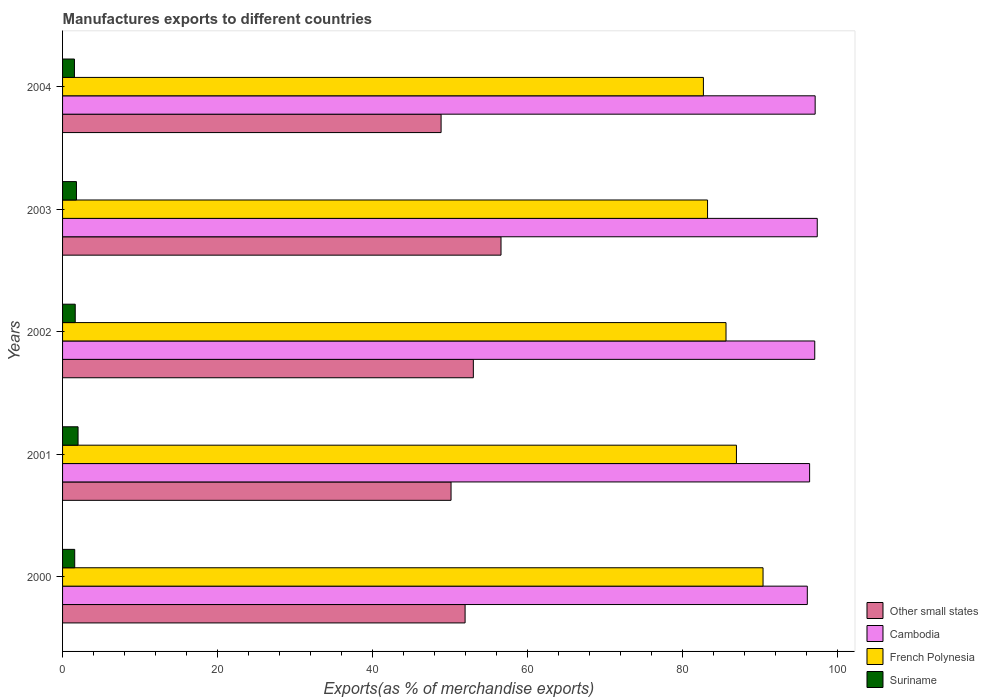How many groups of bars are there?
Keep it short and to the point. 5. How many bars are there on the 3rd tick from the top?
Your response must be concise. 4. What is the label of the 4th group of bars from the top?
Offer a very short reply. 2001. In how many cases, is the number of bars for a given year not equal to the number of legend labels?
Give a very brief answer. 0. What is the percentage of exports to different countries in Suriname in 2004?
Make the answer very short. 1.53. Across all years, what is the maximum percentage of exports to different countries in Other small states?
Ensure brevity in your answer.  56.55. Across all years, what is the minimum percentage of exports to different countries in French Polynesia?
Your answer should be very brief. 82.66. In which year was the percentage of exports to different countries in Suriname minimum?
Ensure brevity in your answer.  2004. What is the total percentage of exports to different countries in Cambodia in the graph?
Your answer should be very brief. 483.84. What is the difference between the percentage of exports to different countries in Cambodia in 2000 and that in 2002?
Keep it short and to the point. -0.96. What is the difference between the percentage of exports to different countries in Other small states in 2000 and the percentage of exports to different countries in French Polynesia in 2003?
Your answer should be compact. -31.27. What is the average percentage of exports to different countries in Other small states per year?
Make the answer very short. 52.08. In the year 2001, what is the difference between the percentage of exports to different countries in Other small states and percentage of exports to different countries in Cambodia?
Offer a very short reply. -46.25. In how many years, is the percentage of exports to different countries in Other small states greater than 88 %?
Your answer should be very brief. 0. What is the ratio of the percentage of exports to different countries in Suriname in 2000 to that in 2003?
Offer a terse response. 0.87. Is the percentage of exports to different countries in French Polynesia in 2001 less than that in 2002?
Keep it short and to the point. No. Is the difference between the percentage of exports to different countries in Other small states in 2002 and 2004 greater than the difference between the percentage of exports to different countries in Cambodia in 2002 and 2004?
Give a very brief answer. Yes. What is the difference between the highest and the second highest percentage of exports to different countries in Other small states?
Offer a very short reply. 3.57. What is the difference between the highest and the lowest percentage of exports to different countries in French Polynesia?
Ensure brevity in your answer.  7.69. In how many years, is the percentage of exports to different countries in Other small states greater than the average percentage of exports to different countries in Other small states taken over all years?
Ensure brevity in your answer.  2. Is the sum of the percentage of exports to different countries in Cambodia in 2003 and 2004 greater than the maximum percentage of exports to different countries in Other small states across all years?
Provide a short and direct response. Yes. What does the 4th bar from the top in 2000 represents?
Your answer should be compact. Other small states. What does the 4th bar from the bottom in 2001 represents?
Your answer should be very brief. Suriname. Is it the case that in every year, the sum of the percentage of exports to different countries in Suriname and percentage of exports to different countries in Cambodia is greater than the percentage of exports to different countries in French Polynesia?
Provide a succinct answer. Yes. How many bars are there?
Make the answer very short. 20. Are all the bars in the graph horizontal?
Your answer should be compact. Yes. Does the graph contain any zero values?
Ensure brevity in your answer.  No. Does the graph contain grids?
Give a very brief answer. No. Where does the legend appear in the graph?
Offer a very short reply. Bottom right. How many legend labels are there?
Offer a very short reply. 4. How are the legend labels stacked?
Your response must be concise. Vertical. What is the title of the graph?
Provide a short and direct response. Manufactures exports to different countries. Does "Georgia" appear as one of the legend labels in the graph?
Provide a succinct answer. No. What is the label or title of the X-axis?
Offer a terse response. Exports(as % of merchandise exports). What is the label or title of the Y-axis?
Give a very brief answer. Years. What is the Exports(as % of merchandise exports) in Other small states in 2000?
Provide a succinct answer. 51.92. What is the Exports(as % of merchandise exports) in Cambodia in 2000?
Offer a very short reply. 96.06. What is the Exports(as % of merchandise exports) of French Polynesia in 2000?
Offer a very short reply. 90.35. What is the Exports(as % of merchandise exports) in Suriname in 2000?
Your answer should be compact. 1.57. What is the Exports(as % of merchandise exports) in Other small states in 2001?
Offer a very short reply. 50.11. What is the Exports(as % of merchandise exports) in Cambodia in 2001?
Your answer should be very brief. 96.35. What is the Exports(as % of merchandise exports) in French Polynesia in 2001?
Make the answer very short. 86.92. What is the Exports(as % of merchandise exports) in Suriname in 2001?
Your response must be concise. 2. What is the Exports(as % of merchandise exports) of Other small states in 2002?
Keep it short and to the point. 52.98. What is the Exports(as % of merchandise exports) of Cambodia in 2002?
Ensure brevity in your answer.  97.02. What is the Exports(as % of merchandise exports) in French Polynesia in 2002?
Make the answer very short. 85.57. What is the Exports(as % of merchandise exports) of Suriname in 2002?
Your answer should be very brief. 1.63. What is the Exports(as % of merchandise exports) of Other small states in 2003?
Offer a terse response. 56.55. What is the Exports(as % of merchandise exports) in Cambodia in 2003?
Offer a terse response. 97.34. What is the Exports(as % of merchandise exports) of French Polynesia in 2003?
Your answer should be very brief. 83.19. What is the Exports(as % of merchandise exports) in Suriname in 2003?
Provide a succinct answer. 1.79. What is the Exports(as % of merchandise exports) in Other small states in 2004?
Offer a very short reply. 48.82. What is the Exports(as % of merchandise exports) in Cambodia in 2004?
Ensure brevity in your answer.  97.07. What is the Exports(as % of merchandise exports) of French Polynesia in 2004?
Provide a succinct answer. 82.66. What is the Exports(as % of merchandise exports) in Suriname in 2004?
Offer a terse response. 1.53. Across all years, what is the maximum Exports(as % of merchandise exports) in Other small states?
Your response must be concise. 56.55. Across all years, what is the maximum Exports(as % of merchandise exports) of Cambodia?
Your answer should be compact. 97.34. Across all years, what is the maximum Exports(as % of merchandise exports) in French Polynesia?
Provide a short and direct response. 90.35. Across all years, what is the maximum Exports(as % of merchandise exports) of Suriname?
Provide a short and direct response. 2. Across all years, what is the minimum Exports(as % of merchandise exports) of Other small states?
Offer a very short reply. 48.82. Across all years, what is the minimum Exports(as % of merchandise exports) in Cambodia?
Your answer should be compact. 96.06. Across all years, what is the minimum Exports(as % of merchandise exports) of French Polynesia?
Keep it short and to the point. 82.66. Across all years, what is the minimum Exports(as % of merchandise exports) in Suriname?
Your answer should be very brief. 1.53. What is the total Exports(as % of merchandise exports) in Other small states in the graph?
Your answer should be very brief. 260.38. What is the total Exports(as % of merchandise exports) of Cambodia in the graph?
Offer a very short reply. 483.84. What is the total Exports(as % of merchandise exports) of French Polynesia in the graph?
Your answer should be compact. 428.68. What is the total Exports(as % of merchandise exports) in Suriname in the graph?
Your response must be concise. 8.52. What is the difference between the Exports(as % of merchandise exports) in Other small states in 2000 and that in 2001?
Your answer should be very brief. 1.81. What is the difference between the Exports(as % of merchandise exports) of Cambodia in 2000 and that in 2001?
Ensure brevity in your answer.  -0.3. What is the difference between the Exports(as % of merchandise exports) in French Polynesia in 2000 and that in 2001?
Your answer should be compact. 3.43. What is the difference between the Exports(as % of merchandise exports) in Suriname in 2000 and that in 2001?
Keep it short and to the point. -0.43. What is the difference between the Exports(as % of merchandise exports) in Other small states in 2000 and that in 2002?
Provide a short and direct response. -1.06. What is the difference between the Exports(as % of merchandise exports) in Cambodia in 2000 and that in 2002?
Provide a succinct answer. -0.96. What is the difference between the Exports(as % of merchandise exports) in French Polynesia in 2000 and that in 2002?
Provide a short and direct response. 4.78. What is the difference between the Exports(as % of merchandise exports) in Suriname in 2000 and that in 2002?
Make the answer very short. -0.07. What is the difference between the Exports(as % of merchandise exports) of Other small states in 2000 and that in 2003?
Provide a short and direct response. -4.63. What is the difference between the Exports(as % of merchandise exports) in Cambodia in 2000 and that in 2003?
Provide a short and direct response. -1.28. What is the difference between the Exports(as % of merchandise exports) in French Polynesia in 2000 and that in 2003?
Offer a very short reply. 7.16. What is the difference between the Exports(as % of merchandise exports) of Suriname in 2000 and that in 2003?
Provide a succinct answer. -0.23. What is the difference between the Exports(as % of merchandise exports) in Other small states in 2000 and that in 2004?
Your answer should be compact. 3.1. What is the difference between the Exports(as % of merchandise exports) of Cambodia in 2000 and that in 2004?
Make the answer very short. -1.01. What is the difference between the Exports(as % of merchandise exports) in French Polynesia in 2000 and that in 2004?
Offer a terse response. 7.69. What is the difference between the Exports(as % of merchandise exports) of Suriname in 2000 and that in 2004?
Provide a succinct answer. 0.04. What is the difference between the Exports(as % of merchandise exports) in Other small states in 2001 and that in 2002?
Offer a very short reply. -2.87. What is the difference between the Exports(as % of merchandise exports) of Cambodia in 2001 and that in 2002?
Make the answer very short. -0.66. What is the difference between the Exports(as % of merchandise exports) of French Polynesia in 2001 and that in 2002?
Provide a succinct answer. 1.35. What is the difference between the Exports(as % of merchandise exports) in Suriname in 2001 and that in 2002?
Offer a very short reply. 0.36. What is the difference between the Exports(as % of merchandise exports) in Other small states in 2001 and that in 2003?
Ensure brevity in your answer.  -6.44. What is the difference between the Exports(as % of merchandise exports) of Cambodia in 2001 and that in 2003?
Offer a very short reply. -0.98. What is the difference between the Exports(as % of merchandise exports) in French Polynesia in 2001 and that in 2003?
Provide a short and direct response. 3.73. What is the difference between the Exports(as % of merchandise exports) of Suriname in 2001 and that in 2003?
Your answer should be compact. 0.21. What is the difference between the Exports(as % of merchandise exports) in Other small states in 2001 and that in 2004?
Ensure brevity in your answer.  1.29. What is the difference between the Exports(as % of merchandise exports) in Cambodia in 2001 and that in 2004?
Provide a short and direct response. -0.72. What is the difference between the Exports(as % of merchandise exports) in French Polynesia in 2001 and that in 2004?
Offer a very short reply. 4.26. What is the difference between the Exports(as % of merchandise exports) in Suriname in 2001 and that in 2004?
Provide a short and direct response. 0.47. What is the difference between the Exports(as % of merchandise exports) of Other small states in 2002 and that in 2003?
Your response must be concise. -3.57. What is the difference between the Exports(as % of merchandise exports) of Cambodia in 2002 and that in 2003?
Give a very brief answer. -0.32. What is the difference between the Exports(as % of merchandise exports) of French Polynesia in 2002 and that in 2003?
Ensure brevity in your answer.  2.38. What is the difference between the Exports(as % of merchandise exports) of Suriname in 2002 and that in 2003?
Ensure brevity in your answer.  -0.16. What is the difference between the Exports(as % of merchandise exports) in Other small states in 2002 and that in 2004?
Give a very brief answer. 4.16. What is the difference between the Exports(as % of merchandise exports) in Cambodia in 2002 and that in 2004?
Provide a succinct answer. -0.05. What is the difference between the Exports(as % of merchandise exports) of French Polynesia in 2002 and that in 2004?
Your response must be concise. 2.92. What is the difference between the Exports(as % of merchandise exports) in Suriname in 2002 and that in 2004?
Keep it short and to the point. 0.1. What is the difference between the Exports(as % of merchandise exports) of Other small states in 2003 and that in 2004?
Offer a terse response. 7.73. What is the difference between the Exports(as % of merchandise exports) in Cambodia in 2003 and that in 2004?
Provide a succinct answer. 0.27. What is the difference between the Exports(as % of merchandise exports) of French Polynesia in 2003 and that in 2004?
Your answer should be very brief. 0.54. What is the difference between the Exports(as % of merchandise exports) in Suriname in 2003 and that in 2004?
Make the answer very short. 0.26. What is the difference between the Exports(as % of merchandise exports) in Other small states in 2000 and the Exports(as % of merchandise exports) in Cambodia in 2001?
Your response must be concise. -44.44. What is the difference between the Exports(as % of merchandise exports) in Other small states in 2000 and the Exports(as % of merchandise exports) in French Polynesia in 2001?
Give a very brief answer. -35. What is the difference between the Exports(as % of merchandise exports) of Other small states in 2000 and the Exports(as % of merchandise exports) of Suriname in 2001?
Give a very brief answer. 49.92. What is the difference between the Exports(as % of merchandise exports) in Cambodia in 2000 and the Exports(as % of merchandise exports) in French Polynesia in 2001?
Make the answer very short. 9.14. What is the difference between the Exports(as % of merchandise exports) in Cambodia in 2000 and the Exports(as % of merchandise exports) in Suriname in 2001?
Make the answer very short. 94.06. What is the difference between the Exports(as % of merchandise exports) of French Polynesia in 2000 and the Exports(as % of merchandise exports) of Suriname in 2001?
Provide a succinct answer. 88.35. What is the difference between the Exports(as % of merchandise exports) of Other small states in 2000 and the Exports(as % of merchandise exports) of Cambodia in 2002?
Keep it short and to the point. -45.1. What is the difference between the Exports(as % of merchandise exports) in Other small states in 2000 and the Exports(as % of merchandise exports) in French Polynesia in 2002?
Your answer should be compact. -33.65. What is the difference between the Exports(as % of merchandise exports) in Other small states in 2000 and the Exports(as % of merchandise exports) in Suriname in 2002?
Your answer should be very brief. 50.28. What is the difference between the Exports(as % of merchandise exports) of Cambodia in 2000 and the Exports(as % of merchandise exports) of French Polynesia in 2002?
Keep it short and to the point. 10.49. What is the difference between the Exports(as % of merchandise exports) of Cambodia in 2000 and the Exports(as % of merchandise exports) of Suriname in 2002?
Offer a very short reply. 94.42. What is the difference between the Exports(as % of merchandise exports) of French Polynesia in 2000 and the Exports(as % of merchandise exports) of Suriname in 2002?
Offer a terse response. 88.71. What is the difference between the Exports(as % of merchandise exports) of Other small states in 2000 and the Exports(as % of merchandise exports) of Cambodia in 2003?
Ensure brevity in your answer.  -45.42. What is the difference between the Exports(as % of merchandise exports) of Other small states in 2000 and the Exports(as % of merchandise exports) of French Polynesia in 2003?
Your answer should be very brief. -31.27. What is the difference between the Exports(as % of merchandise exports) in Other small states in 2000 and the Exports(as % of merchandise exports) in Suriname in 2003?
Your answer should be very brief. 50.13. What is the difference between the Exports(as % of merchandise exports) of Cambodia in 2000 and the Exports(as % of merchandise exports) of French Polynesia in 2003?
Keep it short and to the point. 12.87. What is the difference between the Exports(as % of merchandise exports) in Cambodia in 2000 and the Exports(as % of merchandise exports) in Suriname in 2003?
Give a very brief answer. 94.27. What is the difference between the Exports(as % of merchandise exports) of French Polynesia in 2000 and the Exports(as % of merchandise exports) of Suriname in 2003?
Your response must be concise. 88.56. What is the difference between the Exports(as % of merchandise exports) in Other small states in 2000 and the Exports(as % of merchandise exports) in Cambodia in 2004?
Give a very brief answer. -45.15. What is the difference between the Exports(as % of merchandise exports) in Other small states in 2000 and the Exports(as % of merchandise exports) in French Polynesia in 2004?
Your answer should be compact. -30.74. What is the difference between the Exports(as % of merchandise exports) in Other small states in 2000 and the Exports(as % of merchandise exports) in Suriname in 2004?
Keep it short and to the point. 50.39. What is the difference between the Exports(as % of merchandise exports) of Cambodia in 2000 and the Exports(as % of merchandise exports) of French Polynesia in 2004?
Give a very brief answer. 13.4. What is the difference between the Exports(as % of merchandise exports) in Cambodia in 2000 and the Exports(as % of merchandise exports) in Suriname in 2004?
Give a very brief answer. 94.53. What is the difference between the Exports(as % of merchandise exports) in French Polynesia in 2000 and the Exports(as % of merchandise exports) in Suriname in 2004?
Your answer should be very brief. 88.82. What is the difference between the Exports(as % of merchandise exports) in Other small states in 2001 and the Exports(as % of merchandise exports) in Cambodia in 2002?
Provide a short and direct response. -46.91. What is the difference between the Exports(as % of merchandise exports) in Other small states in 2001 and the Exports(as % of merchandise exports) in French Polynesia in 2002?
Make the answer very short. -35.46. What is the difference between the Exports(as % of merchandise exports) in Other small states in 2001 and the Exports(as % of merchandise exports) in Suriname in 2002?
Offer a terse response. 48.47. What is the difference between the Exports(as % of merchandise exports) of Cambodia in 2001 and the Exports(as % of merchandise exports) of French Polynesia in 2002?
Give a very brief answer. 10.78. What is the difference between the Exports(as % of merchandise exports) of Cambodia in 2001 and the Exports(as % of merchandise exports) of Suriname in 2002?
Provide a succinct answer. 94.72. What is the difference between the Exports(as % of merchandise exports) of French Polynesia in 2001 and the Exports(as % of merchandise exports) of Suriname in 2002?
Make the answer very short. 85.28. What is the difference between the Exports(as % of merchandise exports) of Other small states in 2001 and the Exports(as % of merchandise exports) of Cambodia in 2003?
Your response must be concise. -47.23. What is the difference between the Exports(as % of merchandise exports) of Other small states in 2001 and the Exports(as % of merchandise exports) of French Polynesia in 2003?
Provide a succinct answer. -33.08. What is the difference between the Exports(as % of merchandise exports) in Other small states in 2001 and the Exports(as % of merchandise exports) in Suriname in 2003?
Provide a succinct answer. 48.32. What is the difference between the Exports(as % of merchandise exports) in Cambodia in 2001 and the Exports(as % of merchandise exports) in French Polynesia in 2003?
Your response must be concise. 13.16. What is the difference between the Exports(as % of merchandise exports) in Cambodia in 2001 and the Exports(as % of merchandise exports) in Suriname in 2003?
Your answer should be compact. 94.56. What is the difference between the Exports(as % of merchandise exports) in French Polynesia in 2001 and the Exports(as % of merchandise exports) in Suriname in 2003?
Provide a succinct answer. 85.13. What is the difference between the Exports(as % of merchandise exports) in Other small states in 2001 and the Exports(as % of merchandise exports) in Cambodia in 2004?
Make the answer very short. -46.96. What is the difference between the Exports(as % of merchandise exports) of Other small states in 2001 and the Exports(as % of merchandise exports) of French Polynesia in 2004?
Your answer should be very brief. -32.55. What is the difference between the Exports(as % of merchandise exports) of Other small states in 2001 and the Exports(as % of merchandise exports) of Suriname in 2004?
Make the answer very short. 48.58. What is the difference between the Exports(as % of merchandise exports) of Cambodia in 2001 and the Exports(as % of merchandise exports) of French Polynesia in 2004?
Make the answer very short. 13.7. What is the difference between the Exports(as % of merchandise exports) in Cambodia in 2001 and the Exports(as % of merchandise exports) in Suriname in 2004?
Ensure brevity in your answer.  94.82. What is the difference between the Exports(as % of merchandise exports) of French Polynesia in 2001 and the Exports(as % of merchandise exports) of Suriname in 2004?
Provide a succinct answer. 85.39. What is the difference between the Exports(as % of merchandise exports) in Other small states in 2002 and the Exports(as % of merchandise exports) in Cambodia in 2003?
Make the answer very short. -44.36. What is the difference between the Exports(as % of merchandise exports) in Other small states in 2002 and the Exports(as % of merchandise exports) in French Polynesia in 2003?
Your response must be concise. -30.21. What is the difference between the Exports(as % of merchandise exports) in Other small states in 2002 and the Exports(as % of merchandise exports) in Suriname in 2003?
Make the answer very short. 51.19. What is the difference between the Exports(as % of merchandise exports) in Cambodia in 2002 and the Exports(as % of merchandise exports) in French Polynesia in 2003?
Give a very brief answer. 13.83. What is the difference between the Exports(as % of merchandise exports) in Cambodia in 2002 and the Exports(as % of merchandise exports) in Suriname in 2003?
Your answer should be compact. 95.23. What is the difference between the Exports(as % of merchandise exports) of French Polynesia in 2002 and the Exports(as % of merchandise exports) of Suriname in 2003?
Ensure brevity in your answer.  83.78. What is the difference between the Exports(as % of merchandise exports) in Other small states in 2002 and the Exports(as % of merchandise exports) in Cambodia in 2004?
Offer a terse response. -44.09. What is the difference between the Exports(as % of merchandise exports) of Other small states in 2002 and the Exports(as % of merchandise exports) of French Polynesia in 2004?
Your response must be concise. -29.67. What is the difference between the Exports(as % of merchandise exports) in Other small states in 2002 and the Exports(as % of merchandise exports) in Suriname in 2004?
Your answer should be very brief. 51.45. What is the difference between the Exports(as % of merchandise exports) of Cambodia in 2002 and the Exports(as % of merchandise exports) of French Polynesia in 2004?
Your answer should be compact. 14.36. What is the difference between the Exports(as % of merchandise exports) of Cambodia in 2002 and the Exports(as % of merchandise exports) of Suriname in 2004?
Offer a terse response. 95.49. What is the difference between the Exports(as % of merchandise exports) of French Polynesia in 2002 and the Exports(as % of merchandise exports) of Suriname in 2004?
Ensure brevity in your answer.  84.04. What is the difference between the Exports(as % of merchandise exports) in Other small states in 2003 and the Exports(as % of merchandise exports) in Cambodia in 2004?
Make the answer very short. -40.52. What is the difference between the Exports(as % of merchandise exports) of Other small states in 2003 and the Exports(as % of merchandise exports) of French Polynesia in 2004?
Provide a short and direct response. -26.1. What is the difference between the Exports(as % of merchandise exports) of Other small states in 2003 and the Exports(as % of merchandise exports) of Suriname in 2004?
Your answer should be compact. 55.02. What is the difference between the Exports(as % of merchandise exports) in Cambodia in 2003 and the Exports(as % of merchandise exports) in French Polynesia in 2004?
Your answer should be very brief. 14.68. What is the difference between the Exports(as % of merchandise exports) of Cambodia in 2003 and the Exports(as % of merchandise exports) of Suriname in 2004?
Your answer should be compact. 95.81. What is the difference between the Exports(as % of merchandise exports) in French Polynesia in 2003 and the Exports(as % of merchandise exports) in Suriname in 2004?
Your response must be concise. 81.66. What is the average Exports(as % of merchandise exports) of Other small states per year?
Your answer should be very brief. 52.08. What is the average Exports(as % of merchandise exports) of Cambodia per year?
Keep it short and to the point. 96.77. What is the average Exports(as % of merchandise exports) in French Polynesia per year?
Make the answer very short. 85.74. What is the average Exports(as % of merchandise exports) of Suriname per year?
Ensure brevity in your answer.  1.7. In the year 2000, what is the difference between the Exports(as % of merchandise exports) of Other small states and Exports(as % of merchandise exports) of Cambodia?
Make the answer very short. -44.14. In the year 2000, what is the difference between the Exports(as % of merchandise exports) of Other small states and Exports(as % of merchandise exports) of French Polynesia?
Make the answer very short. -38.43. In the year 2000, what is the difference between the Exports(as % of merchandise exports) of Other small states and Exports(as % of merchandise exports) of Suriname?
Make the answer very short. 50.35. In the year 2000, what is the difference between the Exports(as % of merchandise exports) of Cambodia and Exports(as % of merchandise exports) of French Polynesia?
Your answer should be very brief. 5.71. In the year 2000, what is the difference between the Exports(as % of merchandise exports) in Cambodia and Exports(as % of merchandise exports) in Suriname?
Make the answer very short. 94.49. In the year 2000, what is the difference between the Exports(as % of merchandise exports) in French Polynesia and Exports(as % of merchandise exports) in Suriname?
Your response must be concise. 88.78. In the year 2001, what is the difference between the Exports(as % of merchandise exports) of Other small states and Exports(as % of merchandise exports) of Cambodia?
Your answer should be compact. -46.25. In the year 2001, what is the difference between the Exports(as % of merchandise exports) in Other small states and Exports(as % of merchandise exports) in French Polynesia?
Offer a very short reply. -36.81. In the year 2001, what is the difference between the Exports(as % of merchandise exports) in Other small states and Exports(as % of merchandise exports) in Suriname?
Your response must be concise. 48.11. In the year 2001, what is the difference between the Exports(as % of merchandise exports) of Cambodia and Exports(as % of merchandise exports) of French Polynesia?
Ensure brevity in your answer.  9.44. In the year 2001, what is the difference between the Exports(as % of merchandise exports) in Cambodia and Exports(as % of merchandise exports) in Suriname?
Make the answer very short. 94.35. In the year 2001, what is the difference between the Exports(as % of merchandise exports) of French Polynesia and Exports(as % of merchandise exports) of Suriname?
Provide a short and direct response. 84.92. In the year 2002, what is the difference between the Exports(as % of merchandise exports) of Other small states and Exports(as % of merchandise exports) of Cambodia?
Your answer should be very brief. -44.04. In the year 2002, what is the difference between the Exports(as % of merchandise exports) in Other small states and Exports(as % of merchandise exports) in French Polynesia?
Your answer should be very brief. -32.59. In the year 2002, what is the difference between the Exports(as % of merchandise exports) of Other small states and Exports(as % of merchandise exports) of Suriname?
Your answer should be compact. 51.35. In the year 2002, what is the difference between the Exports(as % of merchandise exports) of Cambodia and Exports(as % of merchandise exports) of French Polynesia?
Offer a terse response. 11.45. In the year 2002, what is the difference between the Exports(as % of merchandise exports) in Cambodia and Exports(as % of merchandise exports) in Suriname?
Give a very brief answer. 95.38. In the year 2002, what is the difference between the Exports(as % of merchandise exports) in French Polynesia and Exports(as % of merchandise exports) in Suriname?
Offer a terse response. 83.94. In the year 2003, what is the difference between the Exports(as % of merchandise exports) of Other small states and Exports(as % of merchandise exports) of Cambodia?
Keep it short and to the point. -40.79. In the year 2003, what is the difference between the Exports(as % of merchandise exports) in Other small states and Exports(as % of merchandise exports) in French Polynesia?
Offer a terse response. -26.64. In the year 2003, what is the difference between the Exports(as % of merchandise exports) of Other small states and Exports(as % of merchandise exports) of Suriname?
Keep it short and to the point. 54.76. In the year 2003, what is the difference between the Exports(as % of merchandise exports) in Cambodia and Exports(as % of merchandise exports) in French Polynesia?
Keep it short and to the point. 14.15. In the year 2003, what is the difference between the Exports(as % of merchandise exports) in Cambodia and Exports(as % of merchandise exports) in Suriname?
Offer a very short reply. 95.55. In the year 2003, what is the difference between the Exports(as % of merchandise exports) in French Polynesia and Exports(as % of merchandise exports) in Suriname?
Offer a terse response. 81.4. In the year 2004, what is the difference between the Exports(as % of merchandise exports) in Other small states and Exports(as % of merchandise exports) in Cambodia?
Provide a succinct answer. -48.25. In the year 2004, what is the difference between the Exports(as % of merchandise exports) in Other small states and Exports(as % of merchandise exports) in French Polynesia?
Offer a terse response. -33.83. In the year 2004, what is the difference between the Exports(as % of merchandise exports) of Other small states and Exports(as % of merchandise exports) of Suriname?
Ensure brevity in your answer.  47.29. In the year 2004, what is the difference between the Exports(as % of merchandise exports) of Cambodia and Exports(as % of merchandise exports) of French Polynesia?
Ensure brevity in your answer.  14.41. In the year 2004, what is the difference between the Exports(as % of merchandise exports) of Cambodia and Exports(as % of merchandise exports) of Suriname?
Keep it short and to the point. 95.54. In the year 2004, what is the difference between the Exports(as % of merchandise exports) of French Polynesia and Exports(as % of merchandise exports) of Suriname?
Provide a succinct answer. 81.12. What is the ratio of the Exports(as % of merchandise exports) in Other small states in 2000 to that in 2001?
Keep it short and to the point. 1.04. What is the ratio of the Exports(as % of merchandise exports) of Cambodia in 2000 to that in 2001?
Ensure brevity in your answer.  1. What is the ratio of the Exports(as % of merchandise exports) of French Polynesia in 2000 to that in 2001?
Provide a succinct answer. 1.04. What is the ratio of the Exports(as % of merchandise exports) in Suriname in 2000 to that in 2001?
Provide a short and direct response. 0.78. What is the ratio of the Exports(as % of merchandise exports) of Other small states in 2000 to that in 2002?
Your answer should be very brief. 0.98. What is the ratio of the Exports(as % of merchandise exports) of French Polynesia in 2000 to that in 2002?
Your response must be concise. 1.06. What is the ratio of the Exports(as % of merchandise exports) of Other small states in 2000 to that in 2003?
Your answer should be very brief. 0.92. What is the ratio of the Exports(as % of merchandise exports) of French Polynesia in 2000 to that in 2003?
Provide a succinct answer. 1.09. What is the ratio of the Exports(as % of merchandise exports) of Suriname in 2000 to that in 2003?
Offer a very short reply. 0.87. What is the ratio of the Exports(as % of merchandise exports) in Other small states in 2000 to that in 2004?
Provide a succinct answer. 1.06. What is the ratio of the Exports(as % of merchandise exports) of French Polynesia in 2000 to that in 2004?
Provide a short and direct response. 1.09. What is the ratio of the Exports(as % of merchandise exports) in Suriname in 2000 to that in 2004?
Provide a short and direct response. 1.02. What is the ratio of the Exports(as % of merchandise exports) in Other small states in 2001 to that in 2002?
Provide a short and direct response. 0.95. What is the ratio of the Exports(as % of merchandise exports) in Cambodia in 2001 to that in 2002?
Your response must be concise. 0.99. What is the ratio of the Exports(as % of merchandise exports) of French Polynesia in 2001 to that in 2002?
Your response must be concise. 1.02. What is the ratio of the Exports(as % of merchandise exports) in Suriname in 2001 to that in 2002?
Provide a short and direct response. 1.22. What is the ratio of the Exports(as % of merchandise exports) of Other small states in 2001 to that in 2003?
Your response must be concise. 0.89. What is the ratio of the Exports(as % of merchandise exports) in Cambodia in 2001 to that in 2003?
Give a very brief answer. 0.99. What is the ratio of the Exports(as % of merchandise exports) of French Polynesia in 2001 to that in 2003?
Offer a very short reply. 1.04. What is the ratio of the Exports(as % of merchandise exports) of Suriname in 2001 to that in 2003?
Your answer should be compact. 1.12. What is the ratio of the Exports(as % of merchandise exports) of Other small states in 2001 to that in 2004?
Offer a very short reply. 1.03. What is the ratio of the Exports(as % of merchandise exports) in Cambodia in 2001 to that in 2004?
Provide a short and direct response. 0.99. What is the ratio of the Exports(as % of merchandise exports) of French Polynesia in 2001 to that in 2004?
Your response must be concise. 1.05. What is the ratio of the Exports(as % of merchandise exports) in Suriname in 2001 to that in 2004?
Your answer should be very brief. 1.31. What is the ratio of the Exports(as % of merchandise exports) in Other small states in 2002 to that in 2003?
Make the answer very short. 0.94. What is the ratio of the Exports(as % of merchandise exports) of Cambodia in 2002 to that in 2003?
Your answer should be very brief. 1. What is the ratio of the Exports(as % of merchandise exports) of French Polynesia in 2002 to that in 2003?
Your answer should be compact. 1.03. What is the ratio of the Exports(as % of merchandise exports) in Suriname in 2002 to that in 2003?
Your response must be concise. 0.91. What is the ratio of the Exports(as % of merchandise exports) of Other small states in 2002 to that in 2004?
Give a very brief answer. 1.09. What is the ratio of the Exports(as % of merchandise exports) of French Polynesia in 2002 to that in 2004?
Provide a succinct answer. 1.04. What is the ratio of the Exports(as % of merchandise exports) in Suriname in 2002 to that in 2004?
Your answer should be very brief. 1.07. What is the ratio of the Exports(as % of merchandise exports) in Other small states in 2003 to that in 2004?
Ensure brevity in your answer.  1.16. What is the ratio of the Exports(as % of merchandise exports) of French Polynesia in 2003 to that in 2004?
Keep it short and to the point. 1.01. What is the ratio of the Exports(as % of merchandise exports) of Suriname in 2003 to that in 2004?
Your answer should be very brief. 1.17. What is the difference between the highest and the second highest Exports(as % of merchandise exports) of Other small states?
Make the answer very short. 3.57. What is the difference between the highest and the second highest Exports(as % of merchandise exports) in Cambodia?
Offer a terse response. 0.27. What is the difference between the highest and the second highest Exports(as % of merchandise exports) of French Polynesia?
Provide a short and direct response. 3.43. What is the difference between the highest and the second highest Exports(as % of merchandise exports) of Suriname?
Make the answer very short. 0.21. What is the difference between the highest and the lowest Exports(as % of merchandise exports) of Other small states?
Keep it short and to the point. 7.73. What is the difference between the highest and the lowest Exports(as % of merchandise exports) of Cambodia?
Offer a very short reply. 1.28. What is the difference between the highest and the lowest Exports(as % of merchandise exports) in French Polynesia?
Ensure brevity in your answer.  7.69. What is the difference between the highest and the lowest Exports(as % of merchandise exports) of Suriname?
Give a very brief answer. 0.47. 